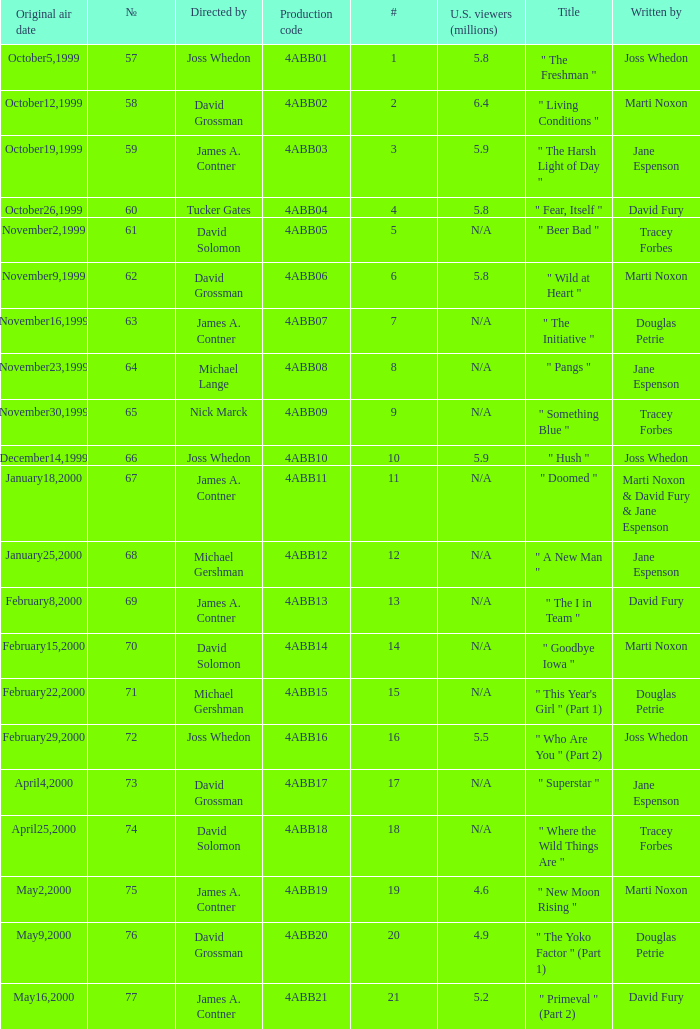What is the title of episode No. 65? " Something Blue ". 